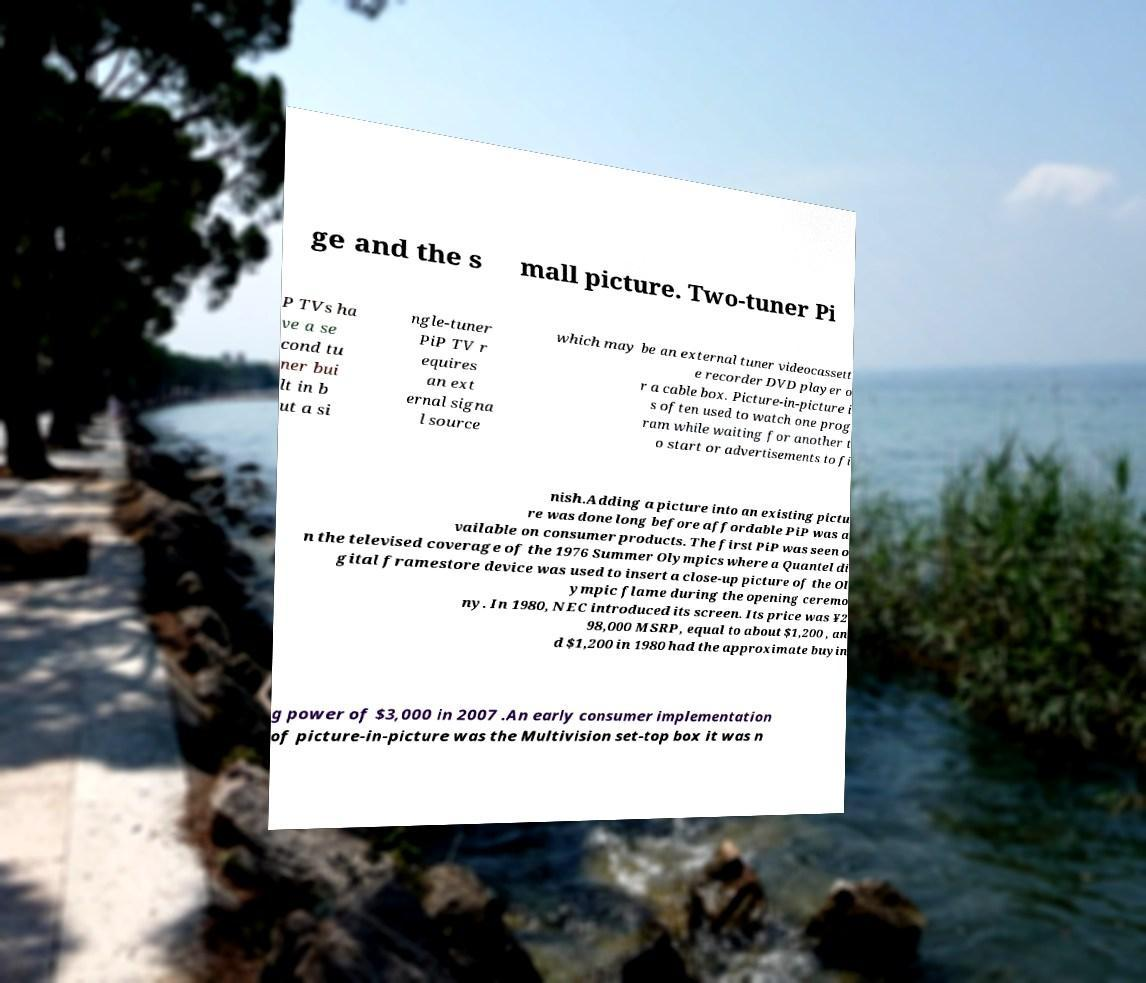Can you accurately transcribe the text from the provided image for me? ge and the s mall picture. Two-tuner Pi P TVs ha ve a se cond tu ner bui lt in b ut a si ngle-tuner PiP TV r equires an ext ernal signa l source which may be an external tuner videocassett e recorder DVD player o r a cable box. Picture-in-picture i s often used to watch one prog ram while waiting for another t o start or advertisements to fi nish.Adding a picture into an existing pictu re was done long before affordable PiP was a vailable on consumer products. The first PiP was seen o n the televised coverage of the 1976 Summer Olympics where a Quantel di gital framestore device was used to insert a close-up picture of the Ol ympic flame during the opening ceremo ny. In 1980, NEC introduced its screen. Its price was ¥2 98,000 MSRP, equal to about $1,200 , an d $1,200 in 1980 had the approximate buyin g power of $3,000 in 2007 .An early consumer implementation of picture-in-picture was the Multivision set-top box it was n 